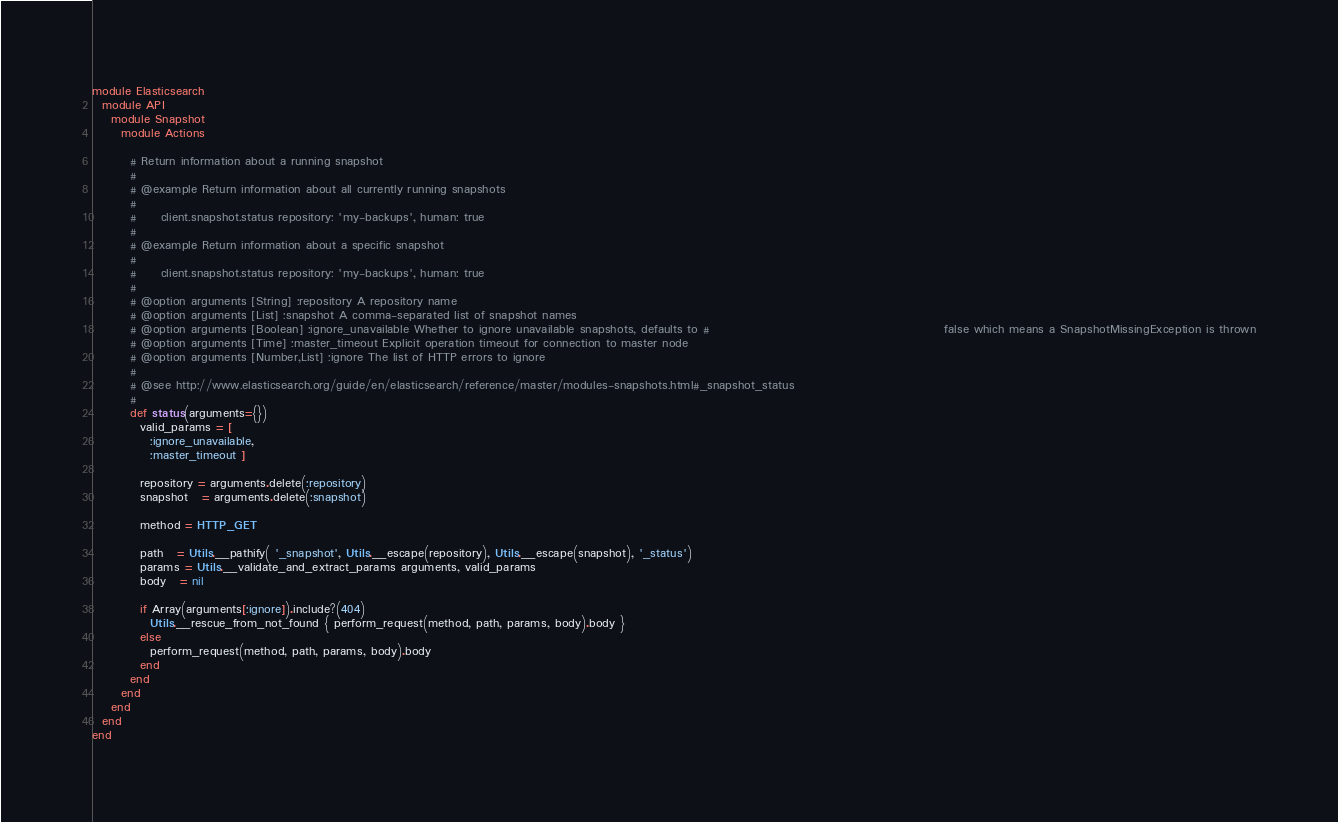<code> <loc_0><loc_0><loc_500><loc_500><_Ruby_>module Elasticsearch
  module API
    module Snapshot
      module Actions

        # Return information about a running snapshot
        #
        # @example Return information about all currently running snapshots
        #
        #     client.snapshot.status repository: 'my-backups', human: true
        #
        # @example Return information about a specific snapshot
        #
        #     client.snapshot.status repository: 'my-backups', human: true
        #
        # @option arguments [String] :repository A repository name
        # @option arguments [List] :snapshot A comma-separated list of snapshot names
        # @option arguments [Boolean] :ignore_unavailable Whether to ignore unavailable snapshots, defaults to #                                                 false which means a SnapshotMissingException is thrown
        # @option arguments [Time] :master_timeout Explicit operation timeout for connection to master node
        # @option arguments [Number,List] :ignore The list of HTTP errors to ignore
        #
        # @see http://www.elasticsearch.org/guide/en/elasticsearch/reference/master/modules-snapshots.html#_snapshot_status
        #
        def status(arguments={})
          valid_params = [
            :ignore_unavailable,
            :master_timeout ]

          repository = arguments.delete(:repository)
          snapshot   = arguments.delete(:snapshot)

          method = HTTP_GET

          path   = Utils.__pathify( '_snapshot', Utils.__escape(repository), Utils.__escape(snapshot), '_status')
          params = Utils.__validate_and_extract_params arguments, valid_params
          body   = nil

          if Array(arguments[:ignore]).include?(404)
            Utils.__rescue_from_not_found { perform_request(method, path, params, body).body }
          else
            perform_request(method, path, params, body).body
          end
        end
      end
    end
  end
end
</code> 